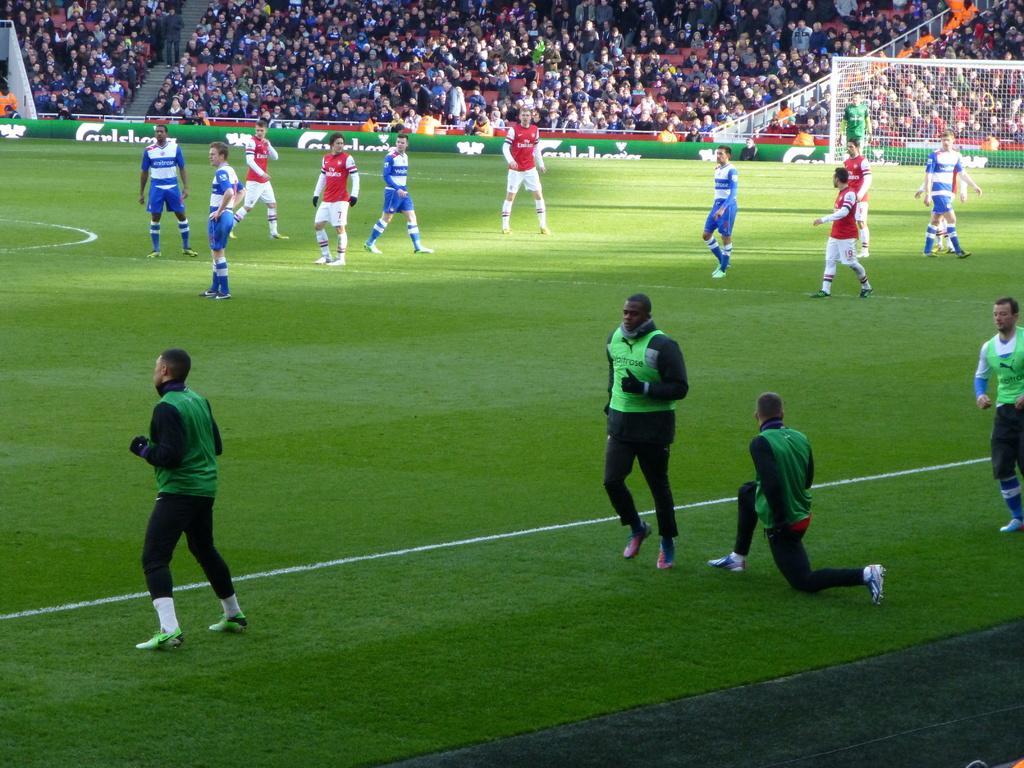In one or two sentences, can you explain what this image depicts? In this picture we see a football stadium with players and audience. 